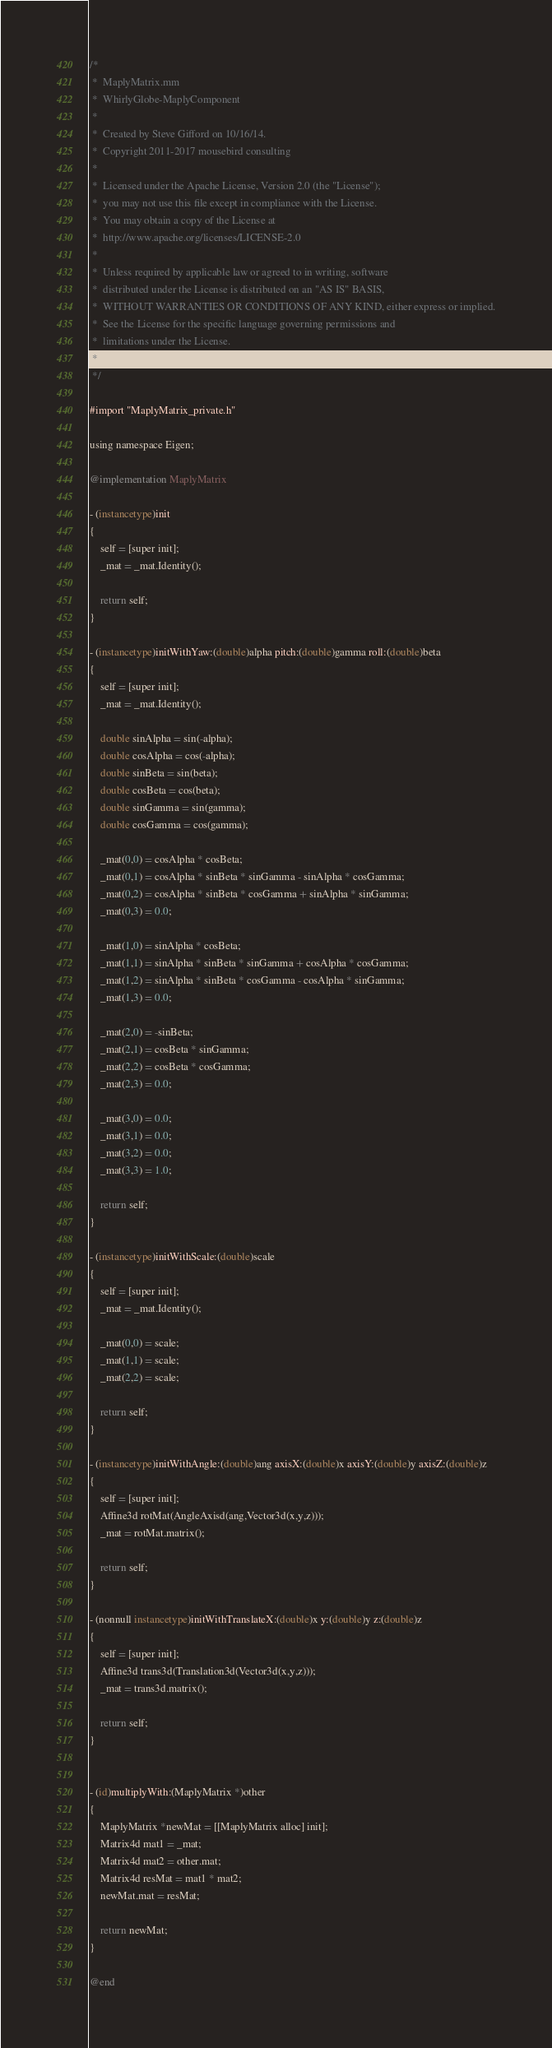<code> <loc_0><loc_0><loc_500><loc_500><_ObjectiveC_>/*
 *  MaplyMatrix.mm
 *  WhirlyGlobe-MaplyComponent
 *
 *  Created by Steve Gifford on 10/16/14.
 *  Copyright 2011-2017 mousebird consulting
 *
 *  Licensed under the Apache License, Version 2.0 (the "License");
 *  you may not use this file except in compliance with the License.
 *  You may obtain a copy of the License at
 *  http://www.apache.org/licenses/LICENSE-2.0
 *
 *  Unless required by applicable law or agreed to in writing, software
 *  distributed under the License is distributed on an "AS IS" BASIS,
 *  WITHOUT WARRANTIES OR CONDITIONS OF ANY KIND, either express or implied.
 *  See the License for the specific language governing permissions and
 *  limitations under the License.
 *
 */

#import "MaplyMatrix_private.h"

using namespace Eigen;

@implementation MaplyMatrix

- (instancetype)init
{
    self = [super init];
    _mat = _mat.Identity();
    
    return self;
}

- (instancetype)initWithYaw:(double)alpha pitch:(double)gamma roll:(double)beta
{
    self = [super init];
    _mat = _mat.Identity();
    
    double sinAlpha = sin(-alpha);
    double cosAlpha = cos(-alpha);
    double sinBeta = sin(beta);
    double cosBeta = cos(beta);
    double sinGamma = sin(gamma);
    double cosGamma = cos(gamma);
    
    _mat(0,0) = cosAlpha * cosBeta;
    _mat(0,1) = cosAlpha * sinBeta * sinGamma - sinAlpha * cosGamma;
    _mat(0,2) = cosAlpha * sinBeta * cosGamma + sinAlpha * sinGamma;
    _mat(0,3) = 0.0;
    
    _mat(1,0) = sinAlpha * cosBeta;
    _mat(1,1) = sinAlpha * sinBeta * sinGamma + cosAlpha * cosGamma;
    _mat(1,2) = sinAlpha * sinBeta * cosGamma - cosAlpha * sinGamma;
    _mat(1,3) = 0.0;
    
    _mat(2,0) = -sinBeta;
    _mat(2,1) = cosBeta * sinGamma;
    _mat(2,2) = cosBeta * cosGamma;
    _mat(2,3) = 0.0;
    
    _mat(3,0) = 0.0;
    _mat(3,1) = 0.0;
    _mat(3,2) = 0.0;
    _mat(3,3) = 1.0;
    
    return self;
}

- (instancetype)initWithScale:(double)scale
{
    self = [super init];
    _mat = _mat.Identity();
    
    _mat(0,0) = scale;
    _mat(1,1) = scale;
    _mat(2,2) = scale;
    
    return self;
}

- (instancetype)initWithAngle:(double)ang axisX:(double)x axisY:(double)y axisZ:(double)z
{
    self = [super init];
    Affine3d rotMat(AngleAxisd(ang,Vector3d(x,y,z)));
    _mat = rotMat.matrix();
    
    return self;
}

- (nonnull instancetype)initWithTranslateX:(double)x y:(double)y z:(double)z
{
    self = [super init];
    Affine3d trans3d(Translation3d(Vector3d(x,y,z)));
    _mat = trans3d.matrix();
    
    return self;
}


- (id)multiplyWith:(MaplyMatrix *)other
{
    MaplyMatrix *newMat = [[MaplyMatrix alloc] init];
    Matrix4d mat1 = _mat;
    Matrix4d mat2 = other.mat;
    Matrix4d resMat = mat1 * mat2;
    newMat.mat = resMat;
    
    return newMat;
}

@end
</code> 